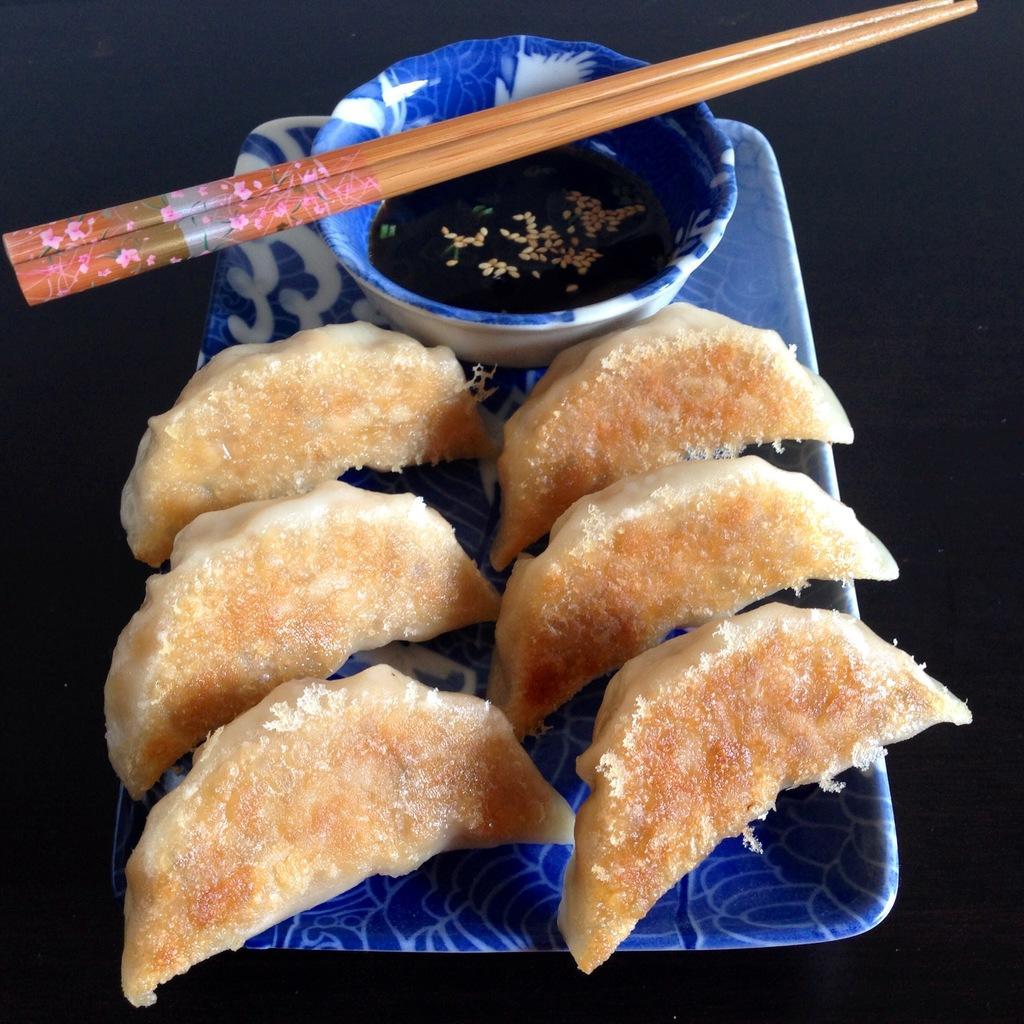Describe this image in one or two sentences. We have a tray. We have a six slices on a tray. We have a bowl on a tray. There are two chopsticks on a bowl. 